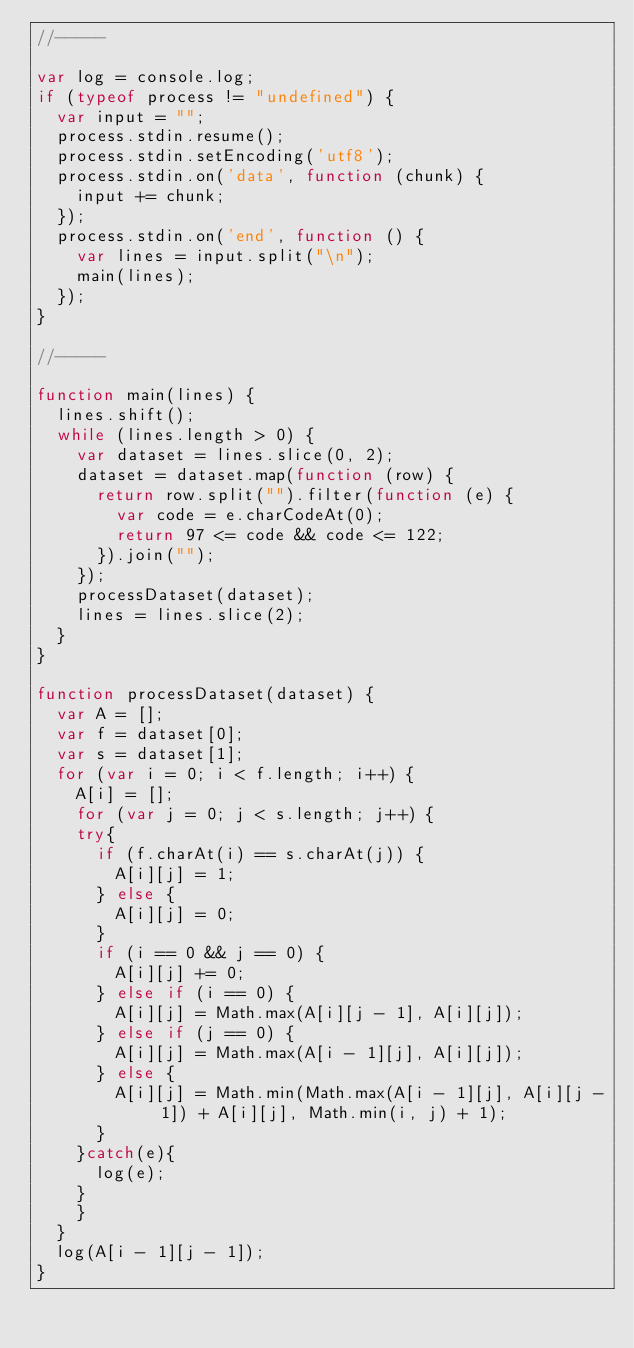<code> <loc_0><loc_0><loc_500><loc_500><_JavaScript_>//-----

var log = console.log;
if (typeof process != "undefined") {
	var input = "";
	process.stdin.resume();
	process.stdin.setEncoding('utf8');
	process.stdin.on('data', function (chunk) {
		input += chunk;
	});
	process.stdin.on('end', function () {
		var lines = input.split("\n");
		main(lines);
	});
}

//-----

function main(lines) {
	lines.shift();
	while (lines.length > 0) {
		var dataset = lines.slice(0, 2);
		dataset = dataset.map(function (row) {
			return row.split("").filter(function (e) {
				var code = e.charCodeAt(0);
				return 97 <= code && code <= 122;
			}).join("");
		});
		processDataset(dataset);
		lines = lines.slice(2);
	}
}

function processDataset(dataset) {
	var A = [];
	var f = dataset[0];
	var s = dataset[1];
	for (var i = 0; i < f.length; i++) {
		A[i] = [];
		for (var j = 0; j < s.length; j++) {
		try{
			if (f.charAt(i) == s.charAt(j)) {
				A[i][j] = 1;
			} else {
				A[i][j] = 0;
			}
			if (i == 0 && j == 0) {
				A[i][j] += 0;
			} else if (i == 0) {
				A[i][j] = Math.max(A[i][j - 1], A[i][j]);
			} else if (j == 0) {
				A[i][j] = Math.max(A[i - 1][j], A[i][j]);
			} else {
				A[i][j] = Math.min(Math.max(A[i - 1][j], A[i][j - 1]) + A[i][j], Math.min(i, j) + 1);
			}
		}catch(e){
			log(e);
		}
		}
	}
	log(A[i - 1][j - 1]);
}</code> 